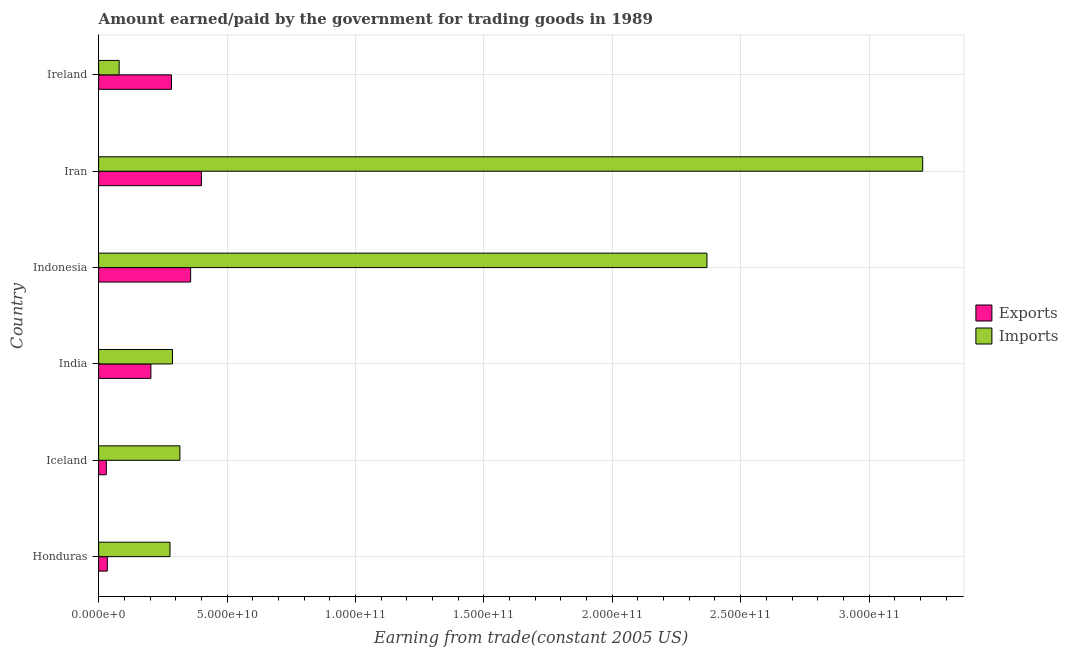How many different coloured bars are there?
Your response must be concise. 2. How many groups of bars are there?
Your response must be concise. 6. Are the number of bars on each tick of the Y-axis equal?
Offer a terse response. Yes. What is the label of the 5th group of bars from the top?
Make the answer very short. Iceland. In how many cases, is the number of bars for a given country not equal to the number of legend labels?
Provide a short and direct response. 0. What is the amount paid for imports in Iceland?
Provide a succinct answer. 3.16e+1. Across all countries, what is the maximum amount earned from exports?
Offer a terse response. 4.00e+1. Across all countries, what is the minimum amount paid for imports?
Your answer should be very brief. 7.99e+09. In which country was the amount paid for imports maximum?
Your answer should be very brief. Iran. In which country was the amount paid for imports minimum?
Provide a succinct answer. Ireland. What is the total amount paid for imports in the graph?
Give a very brief answer. 6.54e+11. What is the difference between the amount earned from exports in India and that in Iran?
Your answer should be compact. -1.97e+1. What is the difference between the amount earned from exports in Iran and the amount paid for imports in India?
Provide a short and direct response. 1.13e+1. What is the average amount earned from exports per country?
Provide a short and direct response. 2.18e+1. What is the difference between the amount paid for imports and amount earned from exports in Ireland?
Provide a short and direct response. -2.04e+1. In how many countries, is the amount earned from exports greater than 310000000000 US$?
Provide a succinct answer. 0. What is the ratio of the amount paid for imports in Indonesia to that in Iran?
Your response must be concise. 0.74. Is the amount paid for imports in Iceland less than that in Ireland?
Ensure brevity in your answer.  No. Is the difference between the amount earned from exports in Iceland and India greater than the difference between the amount paid for imports in Iceland and India?
Your response must be concise. No. What is the difference between the highest and the second highest amount paid for imports?
Offer a very short reply. 8.40e+1. What is the difference between the highest and the lowest amount earned from exports?
Make the answer very short. 3.70e+1. In how many countries, is the amount paid for imports greater than the average amount paid for imports taken over all countries?
Your answer should be very brief. 2. Is the sum of the amount paid for imports in India and Iran greater than the maximum amount earned from exports across all countries?
Offer a very short reply. Yes. What does the 1st bar from the top in Iran represents?
Your answer should be very brief. Imports. What does the 2nd bar from the bottom in Honduras represents?
Your answer should be very brief. Imports. How many bars are there?
Ensure brevity in your answer.  12. What is the difference between two consecutive major ticks on the X-axis?
Give a very brief answer. 5.00e+1. Does the graph contain any zero values?
Your answer should be compact. No. Where does the legend appear in the graph?
Your answer should be compact. Center right. How are the legend labels stacked?
Offer a very short reply. Vertical. What is the title of the graph?
Make the answer very short. Amount earned/paid by the government for trading goods in 1989. What is the label or title of the X-axis?
Offer a terse response. Earning from trade(constant 2005 US). What is the Earning from trade(constant 2005 US) of Exports in Honduras?
Provide a short and direct response. 3.38e+09. What is the Earning from trade(constant 2005 US) in Imports in Honduras?
Give a very brief answer. 2.78e+1. What is the Earning from trade(constant 2005 US) of Exports in Iceland?
Your answer should be compact. 3.00e+09. What is the Earning from trade(constant 2005 US) of Imports in Iceland?
Provide a short and direct response. 3.16e+1. What is the Earning from trade(constant 2005 US) of Exports in India?
Your answer should be compact. 2.04e+1. What is the Earning from trade(constant 2005 US) in Imports in India?
Your answer should be compact. 2.87e+1. What is the Earning from trade(constant 2005 US) of Exports in Indonesia?
Provide a succinct answer. 3.58e+1. What is the Earning from trade(constant 2005 US) of Imports in Indonesia?
Offer a very short reply. 2.37e+11. What is the Earning from trade(constant 2005 US) of Exports in Iran?
Provide a short and direct response. 4.00e+1. What is the Earning from trade(constant 2005 US) of Imports in Iran?
Provide a succinct answer. 3.21e+11. What is the Earning from trade(constant 2005 US) of Exports in Ireland?
Make the answer very short. 2.84e+1. What is the Earning from trade(constant 2005 US) in Imports in Ireland?
Your answer should be very brief. 7.99e+09. Across all countries, what is the maximum Earning from trade(constant 2005 US) in Exports?
Give a very brief answer. 4.00e+1. Across all countries, what is the maximum Earning from trade(constant 2005 US) in Imports?
Offer a terse response. 3.21e+11. Across all countries, what is the minimum Earning from trade(constant 2005 US) in Exports?
Keep it short and to the point. 3.00e+09. Across all countries, what is the minimum Earning from trade(constant 2005 US) in Imports?
Offer a very short reply. 7.99e+09. What is the total Earning from trade(constant 2005 US) in Exports in the graph?
Your answer should be very brief. 1.31e+11. What is the total Earning from trade(constant 2005 US) in Imports in the graph?
Give a very brief answer. 6.54e+11. What is the difference between the Earning from trade(constant 2005 US) in Exports in Honduras and that in Iceland?
Your answer should be very brief. 3.83e+08. What is the difference between the Earning from trade(constant 2005 US) of Imports in Honduras and that in Iceland?
Provide a succinct answer. -3.85e+09. What is the difference between the Earning from trade(constant 2005 US) of Exports in Honduras and that in India?
Make the answer very short. -1.70e+1. What is the difference between the Earning from trade(constant 2005 US) in Imports in Honduras and that in India?
Offer a terse response. -9.57e+08. What is the difference between the Earning from trade(constant 2005 US) of Exports in Honduras and that in Indonesia?
Keep it short and to the point. -3.24e+1. What is the difference between the Earning from trade(constant 2005 US) of Imports in Honduras and that in Indonesia?
Offer a very short reply. -2.09e+11. What is the difference between the Earning from trade(constant 2005 US) in Exports in Honduras and that in Iran?
Give a very brief answer. -3.66e+1. What is the difference between the Earning from trade(constant 2005 US) in Imports in Honduras and that in Iran?
Your answer should be very brief. -2.93e+11. What is the difference between the Earning from trade(constant 2005 US) in Exports in Honduras and that in Ireland?
Make the answer very short. -2.50e+1. What is the difference between the Earning from trade(constant 2005 US) of Imports in Honduras and that in Ireland?
Give a very brief answer. 1.98e+1. What is the difference between the Earning from trade(constant 2005 US) of Exports in Iceland and that in India?
Offer a terse response. -1.74e+1. What is the difference between the Earning from trade(constant 2005 US) of Imports in Iceland and that in India?
Your answer should be compact. 2.90e+09. What is the difference between the Earning from trade(constant 2005 US) in Exports in Iceland and that in Indonesia?
Give a very brief answer. -3.28e+1. What is the difference between the Earning from trade(constant 2005 US) in Imports in Iceland and that in Indonesia?
Your answer should be compact. -2.05e+11. What is the difference between the Earning from trade(constant 2005 US) in Exports in Iceland and that in Iran?
Make the answer very short. -3.70e+1. What is the difference between the Earning from trade(constant 2005 US) of Imports in Iceland and that in Iran?
Your response must be concise. -2.89e+11. What is the difference between the Earning from trade(constant 2005 US) in Exports in Iceland and that in Ireland?
Make the answer very short. -2.54e+1. What is the difference between the Earning from trade(constant 2005 US) of Imports in Iceland and that in Ireland?
Offer a terse response. 2.37e+1. What is the difference between the Earning from trade(constant 2005 US) in Exports in India and that in Indonesia?
Give a very brief answer. -1.55e+1. What is the difference between the Earning from trade(constant 2005 US) of Imports in India and that in Indonesia?
Make the answer very short. -2.08e+11. What is the difference between the Earning from trade(constant 2005 US) in Exports in India and that in Iran?
Keep it short and to the point. -1.97e+1. What is the difference between the Earning from trade(constant 2005 US) in Imports in India and that in Iran?
Provide a succinct answer. -2.92e+11. What is the difference between the Earning from trade(constant 2005 US) of Exports in India and that in Ireland?
Provide a short and direct response. -8.01e+09. What is the difference between the Earning from trade(constant 2005 US) in Imports in India and that in Ireland?
Give a very brief answer. 2.08e+1. What is the difference between the Earning from trade(constant 2005 US) of Exports in Indonesia and that in Iran?
Give a very brief answer. -4.19e+09. What is the difference between the Earning from trade(constant 2005 US) in Imports in Indonesia and that in Iran?
Ensure brevity in your answer.  -8.40e+1. What is the difference between the Earning from trade(constant 2005 US) of Exports in Indonesia and that in Ireland?
Give a very brief answer. 7.46e+09. What is the difference between the Earning from trade(constant 2005 US) of Imports in Indonesia and that in Ireland?
Offer a very short reply. 2.29e+11. What is the difference between the Earning from trade(constant 2005 US) in Exports in Iran and that in Ireland?
Offer a terse response. 1.17e+1. What is the difference between the Earning from trade(constant 2005 US) in Imports in Iran and that in Ireland?
Give a very brief answer. 3.13e+11. What is the difference between the Earning from trade(constant 2005 US) in Exports in Honduras and the Earning from trade(constant 2005 US) in Imports in Iceland?
Provide a short and direct response. -2.83e+1. What is the difference between the Earning from trade(constant 2005 US) in Exports in Honduras and the Earning from trade(constant 2005 US) in Imports in India?
Ensure brevity in your answer.  -2.54e+1. What is the difference between the Earning from trade(constant 2005 US) in Exports in Honduras and the Earning from trade(constant 2005 US) in Imports in Indonesia?
Provide a short and direct response. -2.33e+11. What is the difference between the Earning from trade(constant 2005 US) of Exports in Honduras and the Earning from trade(constant 2005 US) of Imports in Iran?
Keep it short and to the point. -3.17e+11. What is the difference between the Earning from trade(constant 2005 US) of Exports in Honduras and the Earning from trade(constant 2005 US) of Imports in Ireland?
Provide a succinct answer. -4.60e+09. What is the difference between the Earning from trade(constant 2005 US) in Exports in Iceland and the Earning from trade(constant 2005 US) in Imports in India?
Offer a very short reply. -2.58e+1. What is the difference between the Earning from trade(constant 2005 US) of Exports in Iceland and the Earning from trade(constant 2005 US) of Imports in Indonesia?
Offer a very short reply. -2.34e+11. What is the difference between the Earning from trade(constant 2005 US) in Exports in Iceland and the Earning from trade(constant 2005 US) in Imports in Iran?
Ensure brevity in your answer.  -3.18e+11. What is the difference between the Earning from trade(constant 2005 US) of Exports in Iceland and the Earning from trade(constant 2005 US) of Imports in Ireland?
Provide a succinct answer. -4.99e+09. What is the difference between the Earning from trade(constant 2005 US) of Exports in India and the Earning from trade(constant 2005 US) of Imports in Indonesia?
Make the answer very short. -2.17e+11. What is the difference between the Earning from trade(constant 2005 US) in Exports in India and the Earning from trade(constant 2005 US) in Imports in Iran?
Make the answer very short. -3.01e+11. What is the difference between the Earning from trade(constant 2005 US) of Exports in India and the Earning from trade(constant 2005 US) of Imports in Ireland?
Your answer should be very brief. 1.24e+1. What is the difference between the Earning from trade(constant 2005 US) in Exports in Indonesia and the Earning from trade(constant 2005 US) in Imports in Iran?
Your response must be concise. -2.85e+11. What is the difference between the Earning from trade(constant 2005 US) of Exports in Indonesia and the Earning from trade(constant 2005 US) of Imports in Ireland?
Your answer should be very brief. 2.78e+1. What is the difference between the Earning from trade(constant 2005 US) in Exports in Iran and the Earning from trade(constant 2005 US) in Imports in Ireland?
Your answer should be very brief. 3.20e+1. What is the average Earning from trade(constant 2005 US) in Exports per country?
Make the answer very short. 2.18e+1. What is the average Earning from trade(constant 2005 US) in Imports per country?
Keep it short and to the point. 1.09e+11. What is the difference between the Earning from trade(constant 2005 US) in Exports and Earning from trade(constant 2005 US) in Imports in Honduras?
Your response must be concise. -2.44e+1. What is the difference between the Earning from trade(constant 2005 US) in Exports and Earning from trade(constant 2005 US) in Imports in Iceland?
Your answer should be compact. -2.86e+1. What is the difference between the Earning from trade(constant 2005 US) in Exports and Earning from trade(constant 2005 US) in Imports in India?
Keep it short and to the point. -8.39e+09. What is the difference between the Earning from trade(constant 2005 US) in Exports and Earning from trade(constant 2005 US) in Imports in Indonesia?
Offer a very short reply. -2.01e+11. What is the difference between the Earning from trade(constant 2005 US) of Exports and Earning from trade(constant 2005 US) of Imports in Iran?
Your answer should be very brief. -2.81e+11. What is the difference between the Earning from trade(constant 2005 US) of Exports and Earning from trade(constant 2005 US) of Imports in Ireland?
Keep it short and to the point. 2.04e+1. What is the ratio of the Earning from trade(constant 2005 US) of Exports in Honduras to that in Iceland?
Make the answer very short. 1.13. What is the ratio of the Earning from trade(constant 2005 US) in Imports in Honduras to that in Iceland?
Keep it short and to the point. 0.88. What is the ratio of the Earning from trade(constant 2005 US) in Exports in Honduras to that in India?
Ensure brevity in your answer.  0.17. What is the ratio of the Earning from trade(constant 2005 US) of Imports in Honduras to that in India?
Provide a short and direct response. 0.97. What is the ratio of the Earning from trade(constant 2005 US) in Exports in Honduras to that in Indonesia?
Keep it short and to the point. 0.09. What is the ratio of the Earning from trade(constant 2005 US) in Imports in Honduras to that in Indonesia?
Provide a short and direct response. 0.12. What is the ratio of the Earning from trade(constant 2005 US) of Exports in Honduras to that in Iran?
Keep it short and to the point. 0.08. What is the ratio of the Earning from trade(constant 2005 US) in Imports in Honduras to that in Iran?
Offer a very short reply. 0.09. What is the ratio of the Earning from trade(constant 2005 US) in Exports in Honduras to that in Ireland?
Provide a succinct answer. 0.12. What is the ratio of the Earning from trade(constant 2005 US) of Imports in Honduras to that in Ireland?
Provide a succinct answer. 3.48. What is the ratio of the Earning from trade(constant 2005 US) of Exports in Iceland to that in India?
Keep it short and to the point. 0.15. What is the ratio of the Earning from trade(constant 2005 US) of Imports in Iceland to that in India?
Keep it short and to the point. 1.1. What is the ratio of the Earning from trade(constant 2005 US) in Exports in Iceland to that in Indonesia?
Your answer should be compact. 0.08. What is the ratio of the Earning from trade(constant 2005 US) in Imports in Iceland to that in Indonesia?
Your answer should be very brief. 0.13. What is the ratio of the Earning from trade(constant 2005 US) of Exports in Iceland to that in Iran?
Make the answer very short. 0.07. What is the ratio of the Earning from trade(constant 2005 US) in Imports in Iceland to that in Iran?
Offer a very short reply. 0.1. What is the ratio of the Earning from trade(constant 2005 US) in Exports in Iceland to that in Ireland?
Provide a succinct answer. 0.11. What is the ratio of the Earning from trade(constant 2005 US) in Imports in Iceland to that in Ireland?
Offer a very short reply. 3.96. What is the ratio of the Earning from trade(constant 2005 US) of Exports in India to that in Indonesia?
Keep it short and to the point. 0.57. What is the ratio of the Earning from trade(constant 2005 US) in Imports in India to that in Indonesia?
Offer a very short reply. 0.12. What is the ratio of the Earning from trade(constant 2005 US) of Exports in India to that in Iran?
Give a very brief answer. 0.51. What is the ratio of the Earning from trade(constant 2005 US) of Imports in India to that in Iran?
Ensure brevity in your answer.  0.09. What is the ratio of the Earning from trade(constant 2005 US) of Exports in India to that in Ireland?
Make the answer very short. 0.72. What is the ratio of the Earning from trade(constant 2005 US) in Imports in India to that in Ireland?
Offer a terse response. 3.6. What is the ratio of the Earning from trade(constant 2005 US) of Exports in Indonesia to that in Iran?
Provide a succinct answer. 0.9. What is the ratio of the Earning from trade(constant 2005 US) of Imports in Indonesia to that in Iran?
Your answer should be very brief. 0.74. What is the ratio of the Earning from trade(constant 2005 US) of Exports in Indonesia to that in Ireland?
Your answer should be compact. 1.26. What is the ratio of the Earning from trade(constant 2005 US) in Imports in Indonesia to that in Ireland?
Your answer should be compact. 29.66. What is the ratio of the Earning from trade(constant 2005 US) in Exports in Iran to that in Ireland?
Ensure brevity in your answer.  1.41. What is the ratio of the Earning from trade(constant 2005 US) in Imports in Iran to that in Ireland?
Give a very brief answer. 40.18. What is the difference between the highest and the second highest Earning from trade(constant 2005 US) in Exports?
Offer a very short reply. 4.19e+09. What is the difference between the highest and the second highest Earning from trade(constant 2005 US) of Imports?
Your answer should be very brief. 8.40e+1. What is the difference between the highest and the lowest Earning from trade(constant 2005 US) of Exports?
Offer a very short reply. 3.70e+1. What is the difference between the highest and the lowest Earning from trade(constant 2005 US) of Imports?
Provide a succinct answer. 3.13e+11. 